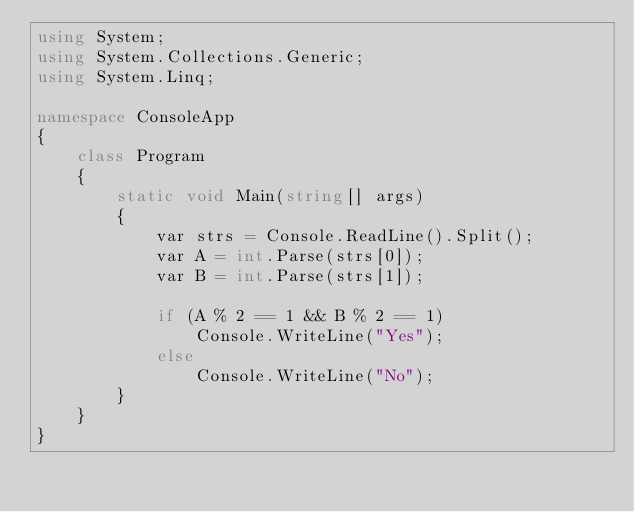<code> <loc_0><loc_0><loc_500><loc_500><_C#_>using System;
using System.Collections.Generic;
using System.Linq;

namespace ConsoleApp
{
    class Program
    {
        static void Main(string[] args)
        {
            var strs = Console.ReadLine().Split();
            var A = int.Parse(strs[0]);
            var B = int.Parse(strs[1]);

            if (A % 2 == 1 && B % 2 == 1)
                Console.WriteLine("Yes");
            else
                Console.WriteLine("No");
        }
    }
}
</code> 